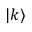<formula> <loc_0><loc_0><loc_500><loc_500>| k \rangle</formula> 